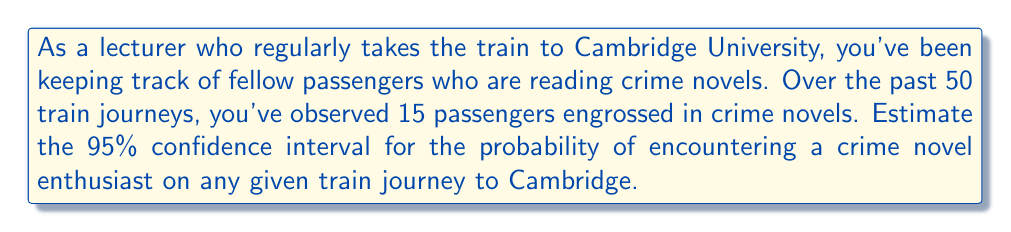Provide a solution to this math problem. Let's approach this step-by-step:

1) First, we need to calculate the point estimate of the probability. This is simply the proportion of observed crime novel readers:

   $\hat{p} = \frac{15}{50} = 0.3$

2) For a 95% confidence interval, we use a z-score of 1.96.

3) The formula for the confidence interval is:

   $$\hat{p} \pm z \sqrt{\frac{\hat{p}(1-\hat{p})}{n}}$$

   where $\hat{p}$ is the point estimate, $z$ is the z-score, and $n$ is the sample size.

4) Let's calculate the margin of error:

   $$\text{Margin of Error} = 1.96 \sqrt{\frac{0.3(1-0.3)}{50}}$$
   $$= 1.96 \sqrt{\frac{0.21}{50}}$$
   $$= 1.96 \sqrt{0.0042}$$
   $$= 1.96 \times 0.0648$$
   $$= 0.1270$$

5) Now, we can calculate the confidence interval:

   Lower bound: $0.3 - 0.1270 = 0.1730$
   Upper bound: $0.3 + 0.1270 = 0.4270$

Therefore, we are 95% confident that the true probability of encountering a crime novel enthusiast on the train to Cambridge is between 0.1730 and 0.4270.
Answer: (0.1730, 0.4270) 